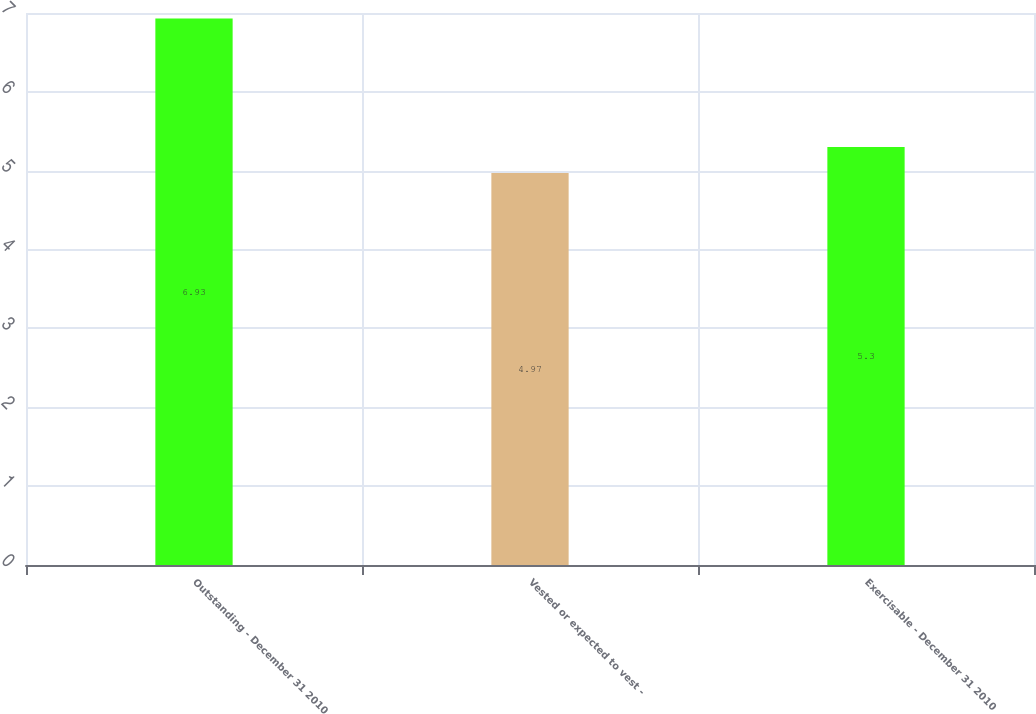Convert chart. <chart><loc_0><loc_0><loc_500><loc_500><bar_chart><fcel>Outstanding - December 31 2010<fcel>Vested or expected to vest -<fcel>Exercisable - December 31 2010<nl><fcel>6.93<fcel>4.97<fcel>5.3<nl></chart> 